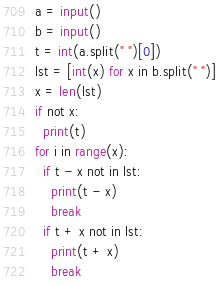Convert code to text. <code><loc_0><loc_0><loc_500><loc_500><_Python_>a = input()
b = input()
t = int(a.split(" ")[0])
lst = [int(x) for x in b.split(" ")]
x = len(lst)
if not x:
  print(t)
for i in range(x):
  if t - x not in lst:
    print(t - x)
    break
  if t + x not in lst:
    print(t + x)
    break
</code> 